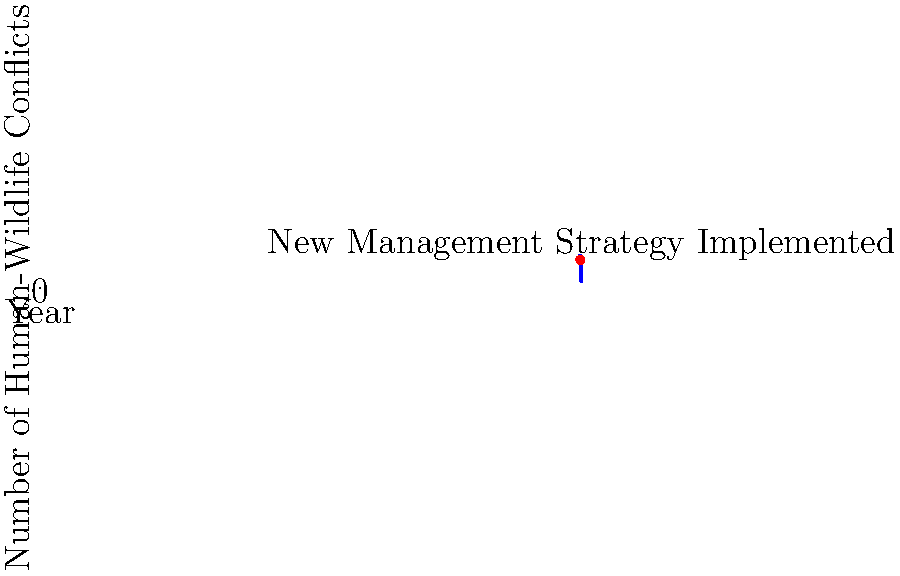The chart shows the number of human-wildlife conflicts in a community from 2015 to 2020. A new wildlife management strategy was implemented in 2016. Calculate the percentage reduction in conflicts between 2016 and 2020. How might this data change your initial perspective on the wildlife management policy? To calculate the percentage reduction in conflicts between 2016 and 2020:

1. Identify the number of conflicts in 2016 and 2020:
   2016: 105 conflicts
   2020: 25 conflicts

2. Calculate the difference:
   105 - 25 = 80 conflicts reduced

3. Calculate the percentage reduction:
   Percentage reduction = (Reduction / Original Value) × 100
   = (80 / 105) × 100
   ≈ 76.19%

4. Interpreting the results:
   The data shows a significant reduction (76.19%) in human-wildlife conflicts over four years following the implementation of the new management strategy.

5. Perspective change:
   As a community member initially opposed to policy changes, this data might lead to a reevaluation of the initial stance. The substantial decrease in conflicts suggests that the wildlife biologist's work and the new management strategies have been effective in reducing human-wildlife interactions, potentially improving community safety and coexistence with local wildlife.
Answer: 76.19% reduction; data suggests effective management, potentially changing initial opposition to support. 